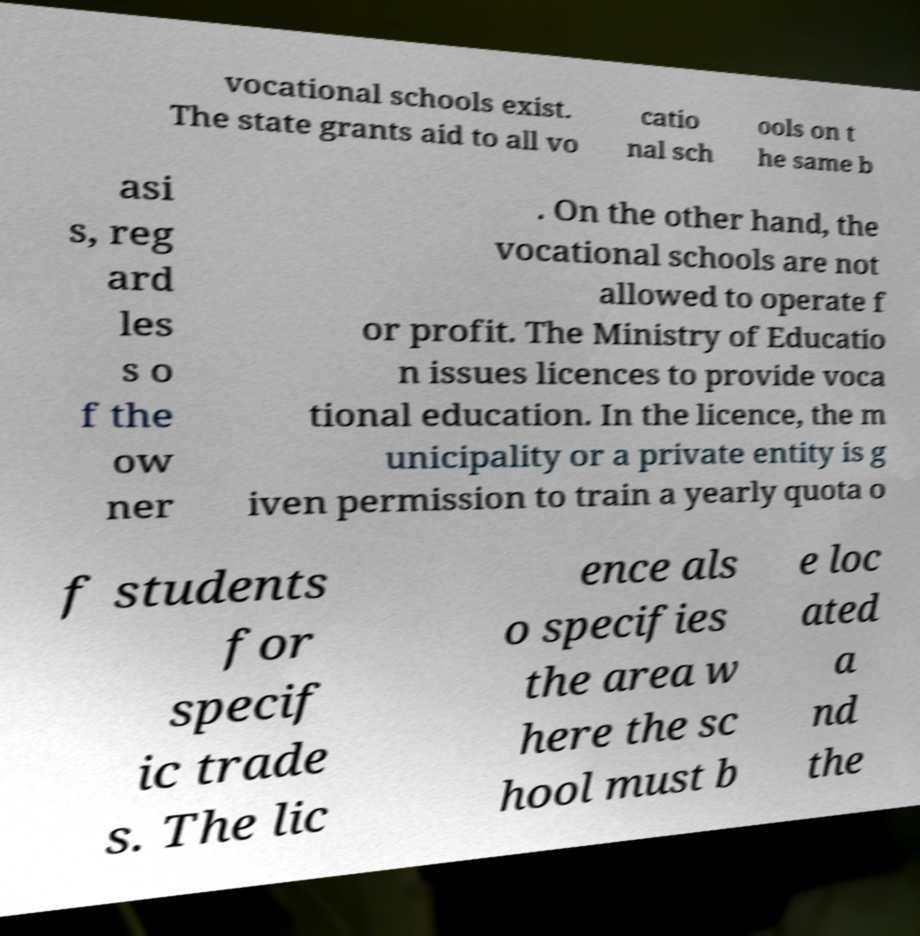Please identify and transcribe the text found in this image. vocational schools exist. The state grants aid to all vo catio nal sch ools on t he same b asi s, reg ard les s o f the ow ner . On the other hand, the vocational schools are not allowed to operate f or profit. The Ministry of Educatio n issues licences to provide voca tional education. In the licence, the m unicipality or a private entity is g iven permission to train a yearly quota o f students for specif ic trade s. The lic ence als o specifies the area w here the sc hool must b e loc ated a nd the 